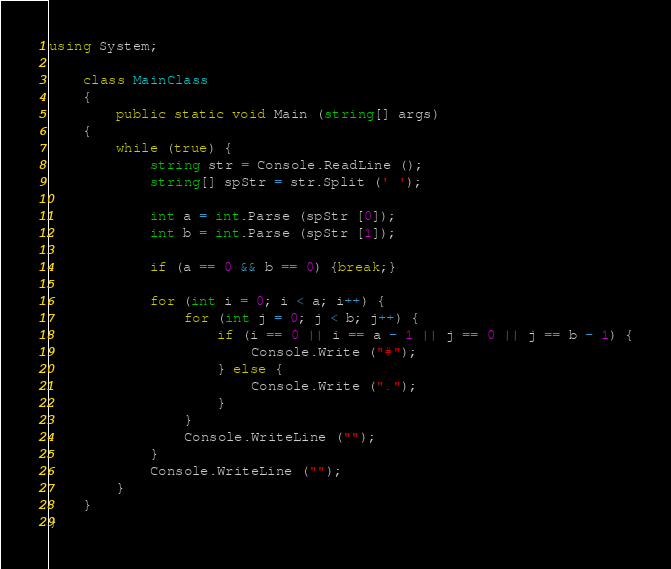<code> <loc_0><loc_0><loc_500><loc_500><_C#_>using System;

	class MainClass
	{
		public static void Main (string[] args)
	{
		while (true) {
			string str = Console.ReadLine ();
			string[] spStr = str.Split (' ');

			int a = int.Parse (spStr [0]);
			int b = int.Parse (spStr [1]);

			if (a == 0 && b == 0) {break;}

			for (int i = 0; i < a; i++) {
				for (int j = 0; j < b; j++) {
					if (i == 0 || i == a - 1 || j == 0 || j == b - 1) {
						Console.Write ("#");
					} else {
						Console.Write (".");
					}
				}
				Console.WriteLine ("");
			}
			Console.WriteLine ("");
		}
	}
}</code> 